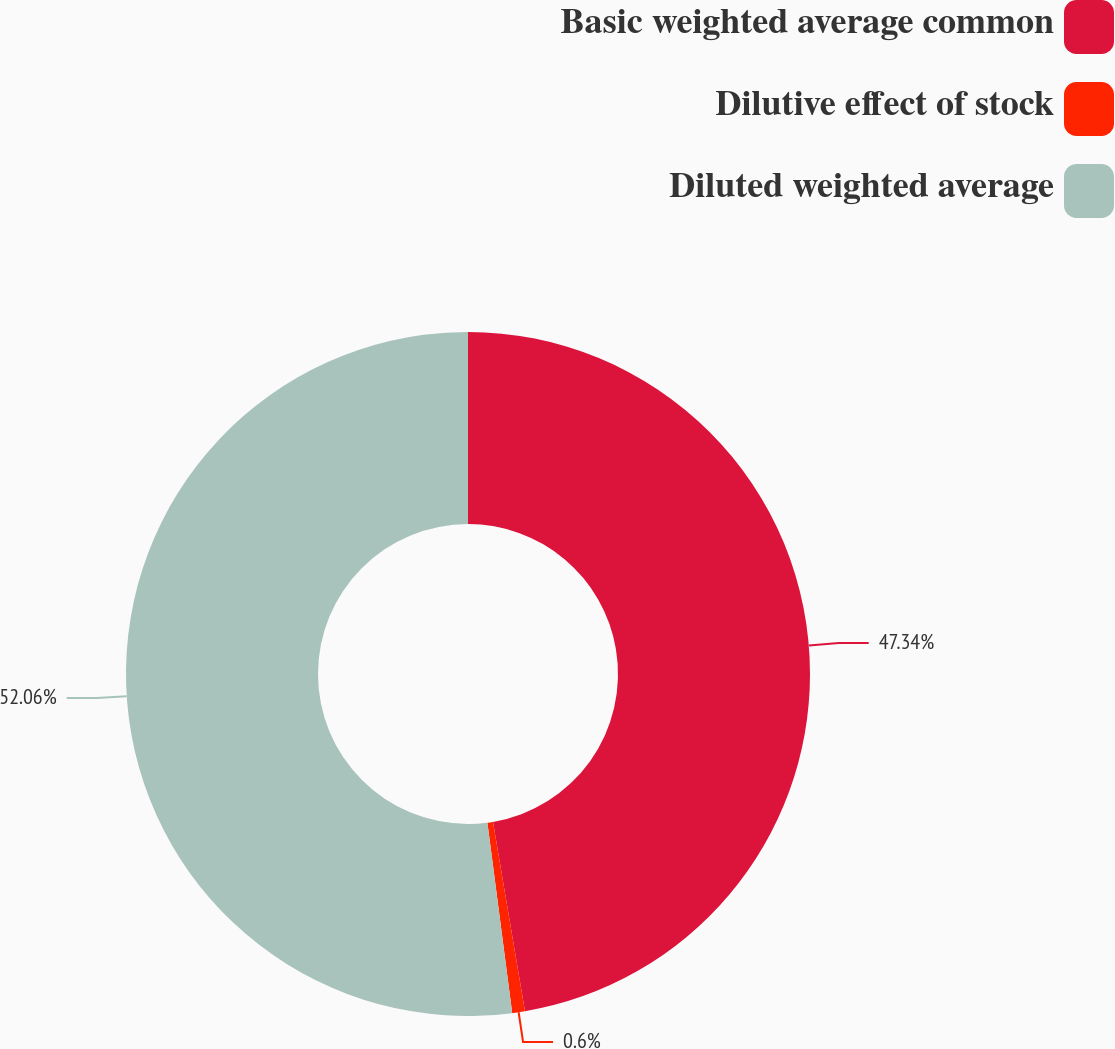<chart> <loc_0><loc_0><loc_500><loc_500><pie_chart><fcel>Basic weighted average common<fcel>Dilutive effect of stock<fcel>Diluted weighted average<nl><fcel>47.34%<fcel>0.6%<fcel>52.07%<nl></chart> 